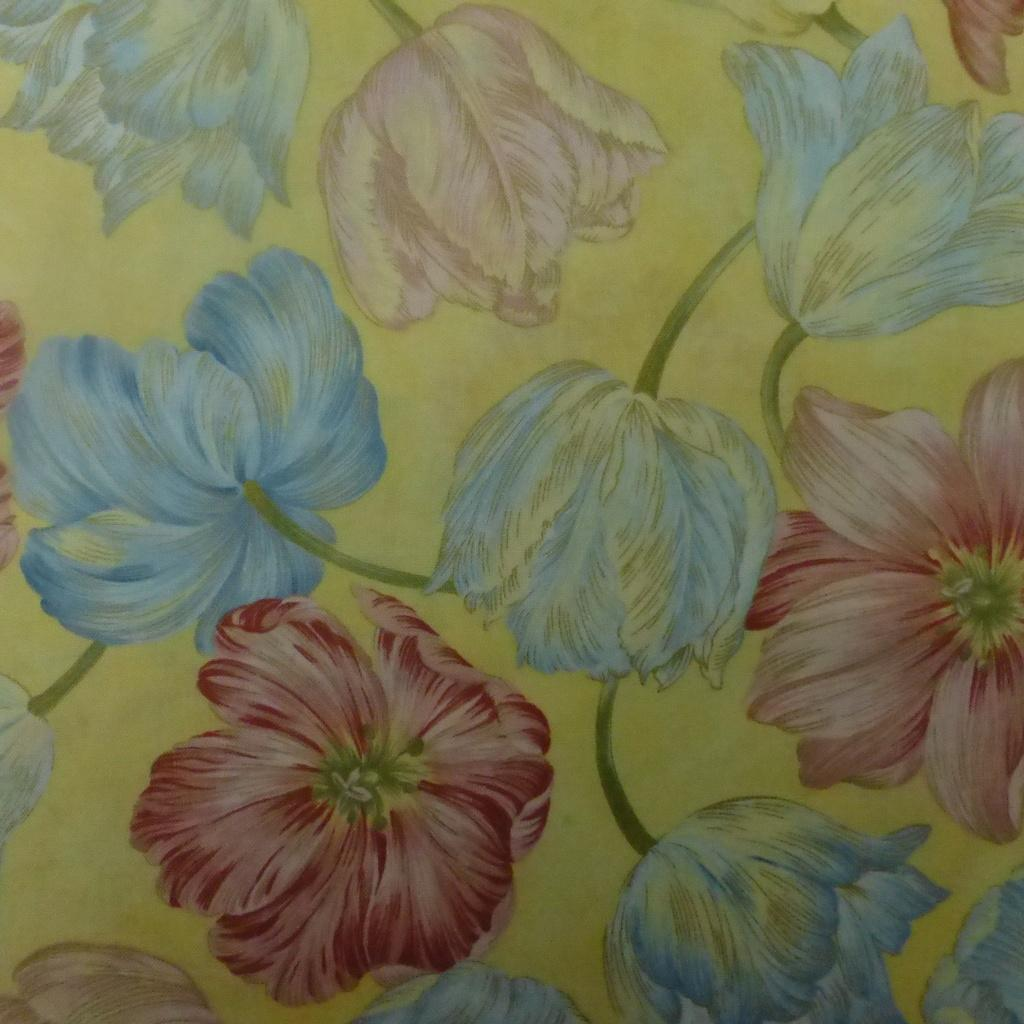What type of artwork is depicted in the image? There are flower paintings in the image. What colors are the flowers in the paintings? The flowers are in blue and red colors. What is the color of the paper on which the paintings are made? The paper is in yellow color. What type of skin can be seen on the deer in the image? There are no deer present in the image; it features flower paintings on yellow paper. What type of bread is visible in the image? There is no bread present in the image; it features flower paintings on yellow paper. 